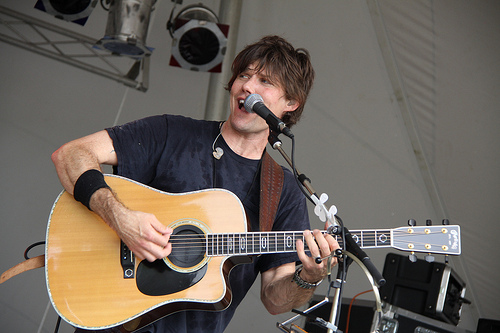<image>
Can you confirm if the guitar is to the right of the microphone? No. The guitar is not to the right of the microphone. The horizontal positioning shows a different relationship. Is there a guitar next to the fingers? Yes. The guitar is positioned adjacent to the fingers, located nearby in the same general area. Is there a person in front of the guitar? No. The person is not in front of the guitar. The spatial positioning shows a different relationship between these objects. 